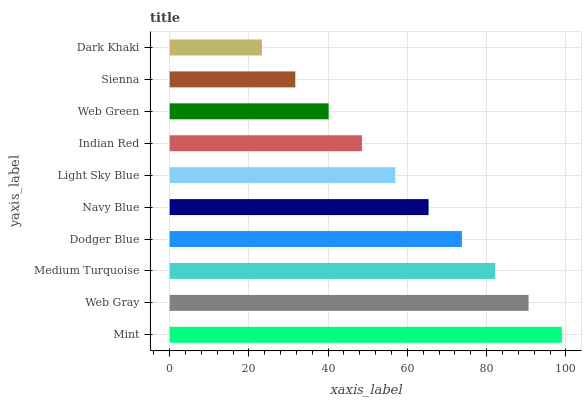Is Dark Khaki the minimum?
Answer yes or no. Yes. Is Mint the maximum?
Answer yes or no. Yes. Is Web Gray the minimum?
Answer yes or no. No. Is Web Gray the maximum?
Answer yes or no. No. Is Mint greater than Web Gray?
Answer yes or no. Yes. Is Web Gray less than Mint?
Answer yes or no. Yes. Is Web Gray greater than Mint?
Answer yes or no. No. Is Mint less than Web Gray?
Answer yes or no. No. Is Navy Blue the high median?
Answer yes or no. Yes. Is Light Sky Blue the low median?
Answer yes or no. Yes. Is Mint the high median?
Answer yes or no. No. Is Dodger Blue the low median?
Answer yes or no. No. 